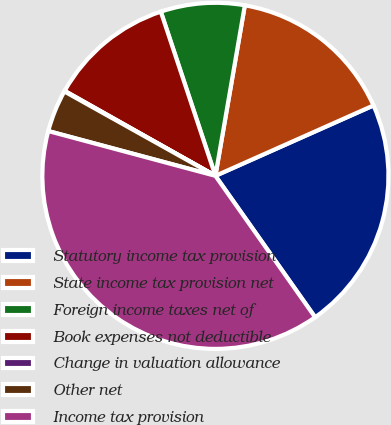Convert chart to OTSL. <chart><loc_0><loc_0><loc_500><loc_500><pie_chart><fcel>Statutory income tax provision<fcel>State income tax provision net<fcel>Foreign income taxes net of<fcel>Book expenses not deductible<fcel>Change in valuation allowance<fcel>Other net<fcel>Income tax provision<nl><fcel>21.89%<fcel>15.61%<fcel>7.83%<fcel>11.72%<fcel>0.06%<fcel>3.94%<fcel>38.94%<nl></chart> 